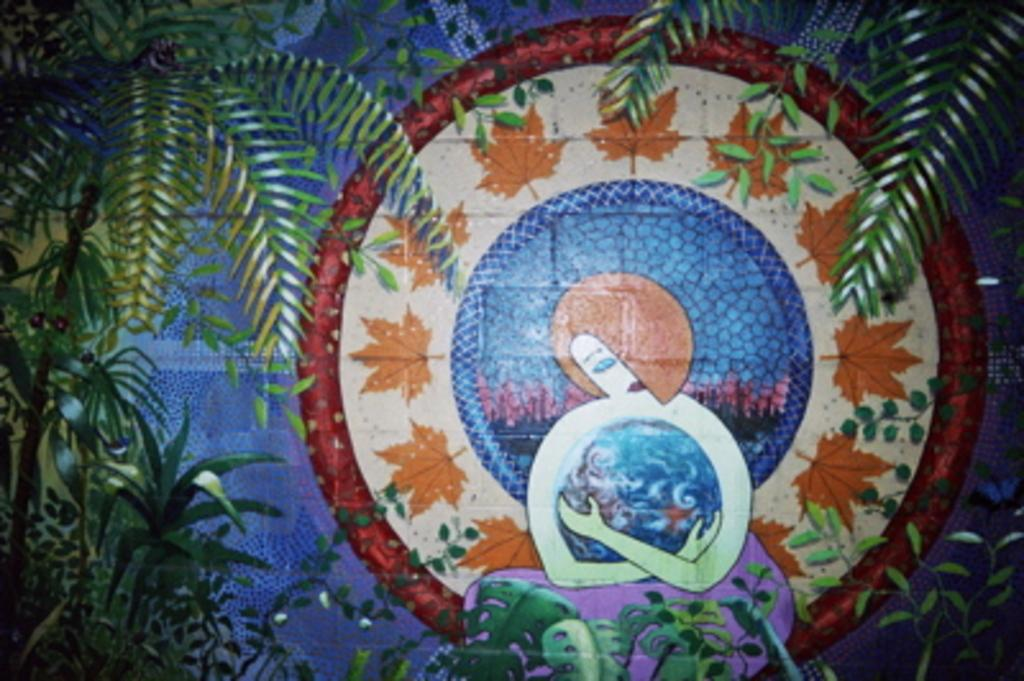What type of natural elements can be seen in the image? There are trees in the image. What can be found in the background of the image? There is a wall with a painting in the background. What is the subject of the painting? The painting depicts a woman. Are there any additional elements on the painting? Yes, the painting has leaves on it. Can you tell me how many bats are hanging from the trees in the image? There are no bats visible in the image; it only features trees and a painting on a wall. What type of wax is used to create the painting in the image? There is no information about the materials used to create the painting in the image. 